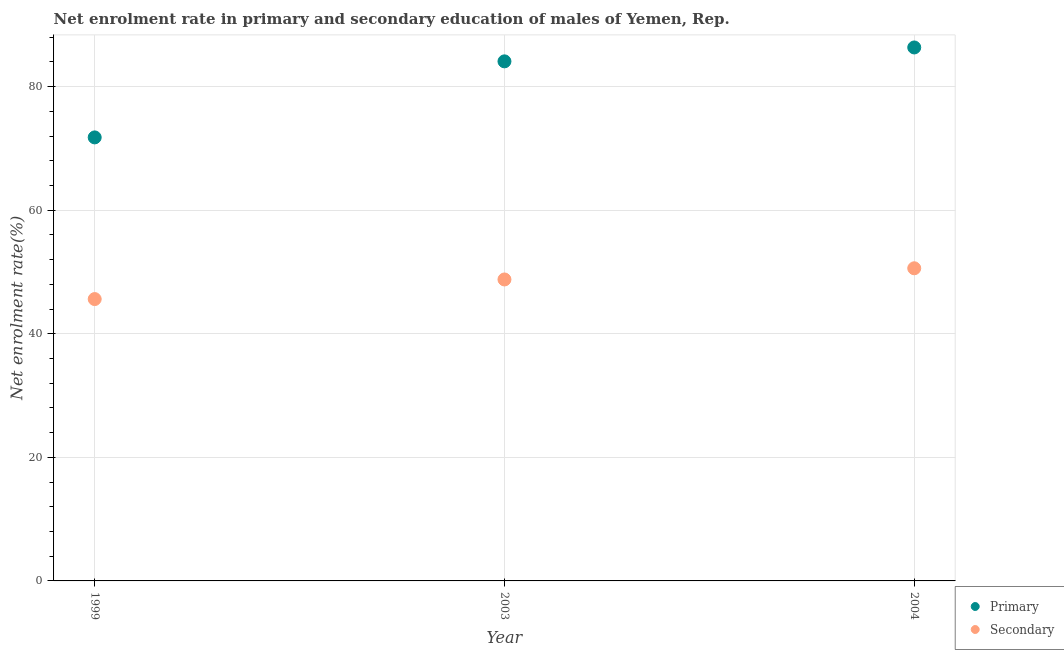Is the number of dotlines equal to the number of legend labels?
Give a very brief answer. Yes. What is the enrollment rate in primary education in 2004?
Offer a terse response. 86.35. Across all years, what is the maximum enrollment rate in primary education?
Keep it short and to the point. 86.35. Across all years, what is the minimum enrollment rate in primary education?
Give a very brief answer. 71.79. What is the total enrollment rate in secondary education in the graph?
Your answer should be very brief. 145.03. What is the difference between the enrollment rate in primary education in 2003 and that in 2004?
Your answer should be very brief. -2.25. What is the difference between the enrollment rate in secondary education in 1999 and the enrollment rate in primary education in 2004?
Offer a terse response. -40.73. What is the average enrollment rate in primary education per year?
Your answer should be very brief. 80.75. In the year 1999, what is the difference between the enrollment rate in primary education and enrollment rate in secondary education?
Your answer should be very brief. 26.17. In how many years, is the enrollment rate in secondary education greater than 84 %?
Your answer should be very brief. 0. What is the ratio of the enrollment rate in secondary education in 1999 to that in 2003?
Your response must be concise. 0.93. Is the enrollment rate in secondary education in 2003 less than that in 2004?
Provide a short and direct response. Yes. Is the difference between the enrollment rate in secondary education in 2003 and 2004 greater than the difference between the enrollment rate in primary education in 2003 and 2004?
Make the answer very short. Yes. What is the difference between the highest and the second highest enrollment rate in primary education?
Make the answer very short. 2.25. What is the difference between the highest and the lowest enrollment rate in secondary education?
Your answer should be compact. 4.98. Is the sum of the enrollment rate in secondary education in 1999 and 2003 greater than the maximum enrollment rate in primary education across all years?
Your answer should be very brief. Yes. Does the enrollment rate in secondary education monotonically increase over the years?
Offer a very short reply. Yes. Is the enrollment rate in secondary education strictly less than the enrollment rate in primary education over the years?
Your response must be concise. Yes. How many dotlines are there?
Provide a succinct answer. 2. What is the difference between two consecutive major ticks on the Y-axis?
Make the answer very short. 20. Are the values on the major ticks of Y-axis written in scientific E-notation?
Offer a very short reply. No. Does the graph contain grids?
Your response must be concise. Yes. How are the legend labels stacked?
Make the answer very short. Vertical. What is the title of the graph?
Ensure brevity in your answer.  Net enrolment rate in primary and secondary education of males of Yemen, Rep. What is the label or title of the X-axis?
Ensure brevity in your answer.  Year. What is the label or title of the Y-axis?
Your response must be concise. Net enrolment rate(%). What is the Net enrolment rate(%) of Primary in 1999?
Give a very brief answer. 71.79. What is the Net enrolment rate(%) in Secondary in 1999?
Your answer should be compact. 45.62. What is the Net enrolment rate(%) of Primary in 2003?
Provide a succinct answer. 84.1. What is the Net enrolment rate(%) of Secondary in 2003?
Your response must be concise. 48.8. What is the Net enrolment rate(%) in Primary in 2004?
Provide a succinct answer. 86.35. What is the Net enrolment rate(%) of Secondary in 2004?
Provide a succinct answer. 50.61. Across all years, what is the maximum Net enrolment rate(%) in Primary?
Provide a short and direct response. 86.35. Across all years, what is the maximum Net enrolment rate(%) in Secondary?
Ensure brevity in your answer.  50.61. Across all years, what is the minimum Net enrolment rate(%) in Primary?
Offer a terse response. 71.79. Across all years, what is the minimum Net enrolment rate(%) in Secondary?
Make the answer very short. 45.62. What is the total Net enrolment rate(%) in Primary in the graph?
Provide a succinct answer. 242.25. What is the total Net enrolment rate(%) in Secondary in the graph?
Keep it short and to the point. 145.03. What is the difference between the Net enrolment rate(%) of Primary in 1999 and that in 2003?
Give a very brief answer. -12.31. What is the difference between the Net enrolment rate(%) in Secondary in 1999 and that in 2003?
Make the answer very short. -3.17. What is the difference between the Net enrolment rate(%) in Primary in 1999 and that in 2004?
Your response must be concise. -14.56. What is the difference between the Net enrolment rate(%) in Secondary in 1999 and that in 2004?
Provide a succinct answer. -4.98. What is the difference between the Net enrolment rate(%) in Primary in 2003 and that in 2004?
Make the answer very short. -2.25. What is the difference between the Net enrolment rate(%) of Secondary in 2003 and that in 2004?
Your response must be concise. -1.81. What is the difference between the Net enrolment rate(%) of Primary in 1999 and the Net enrolment rate(%) of Secondary in 2003?
Ensure brevity in your answer.  23. What is the difference between the Net enrolment rate(%) of Primary in 1999 and the Net enrolment rate(%) of Secondary in 2004?
Ensure brevity in your answer.  21.19. What is the difference between the Net enrolment rate(%) of Primary in 2003 and the Net enrolment rate(%) of Secondary in 2004?
Your answer should be compact. 33.5. What is the average Net enrolment rate(%) of Primary per year?
Offer a terse response. 80.75. What is the average Net enrolment rate(%) of Secondary per year?
Offer a very short reply. 48.34. In the year 1999, what is the difference between the Net enrolment rate(%) in Primary and Net enrolment rate(%) in Secondary?
Offer a very short reply. 26.17. In the year 2003, what is the difference between the Net enrolment rate(%) of Primary and Net enrolment rate(%) of Secondary?
Your answer should be compact. 35.31. In the year 2004, what is the difference between the Net enrolment rate(%) in Primary and Net enrolment rate(%) in Secondary?
Ensure brevity in your answer.  35.75. What is the ratio of the Net enrolment rate(%) of Primary in 1999 to that in 2003?
Keep it short and to the point. 0.85. What is the ratio of the Net enrolment rate(%) in Secondary in 1999 to that in 2003?
Provide a succinct answer. 0.94. What is the ratio of the Net enrolment rate(%) in Primary in 1999 to that in 2004?
Make the answer very short. 0.83. What is the ratio of the Net enrolment rate(%) in Secondary in 1999 to that in 2004?
Provide a short and direct response. 0.9. What is the ratio of the Net enrolment rate(%) of Primary in 2003 to that in 2004?
Offer a very short reply. 0.97. What is the ratio of the Net enrolment rate(%) in Secondary in 2003 to that in 2004?
Ensure brevity in your answer.  0.96. What is the difference between the highest and the second highest Net enrolment rate(%) of Primary?
Ensure brevity in your answer.  2.25. What is the difference between the highest and the second highest Net enrolment rate(%) of Secondary?
Provide a short and direct response. 1.81. What is the difference between the highest and the lowest Net enrolment rate(%) in Primary?
Your response must be concise. 14.56. What is the difference between the highest and the lowest Net enrolment rate(%) of Secondary?
Your answer should be very brief. 4.98. 